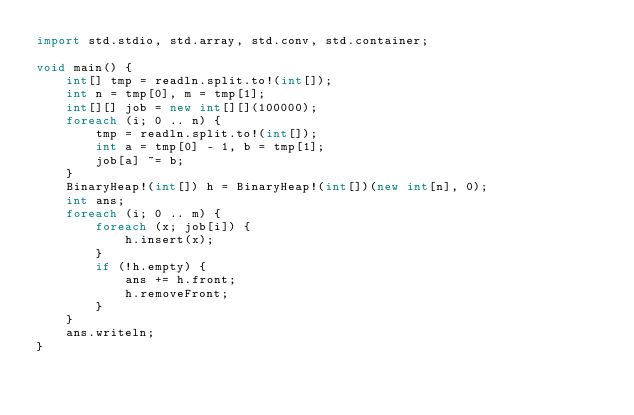Convert code to text. <code><loc_0><loc_0><loc_500><loc_500><_D_>import std.stdio, std.array, std.conv, std.container;

void main() {
    int[] tmp = readln.split.to!(int[]);
    int n = tmp[0], m = tmp[1];
    int[][] job = new int[][](100000);
    foreach (i; 0 .. n) {
        tmp = readln.split.to!(int[]);
        int a = tmp[0] - 1, b = tmp[1];
        job[a] ~= b;
    }
    BinaryHeap!(int[]) h = BinaryHeap!(int[])(new int[n], 0);
    int ans;
    foreach (i; 0 .. m) {
        foreach (x; job[i]) {
            h.insert(x);
        }
        if (!h.empty) {
            ans += h.front;
            h.removeFront;
        }
    }
    ans.writeln;
}</code> 